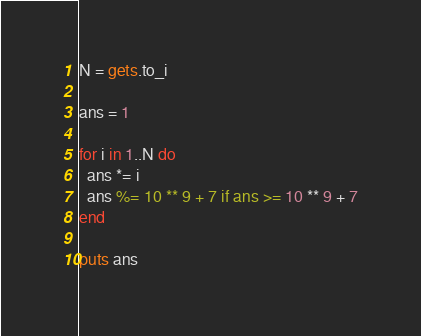Convert code to text. <code><loc_0><loc_0><loc_500><loc_500><_Ruby_>N = gets.to_i

ans = 1

for i in 1..N do
  ans *= i
  ans %= 10 ** 9 + 7 if ans >= 10 ** 9 + 7
end

puts ans
</code> 